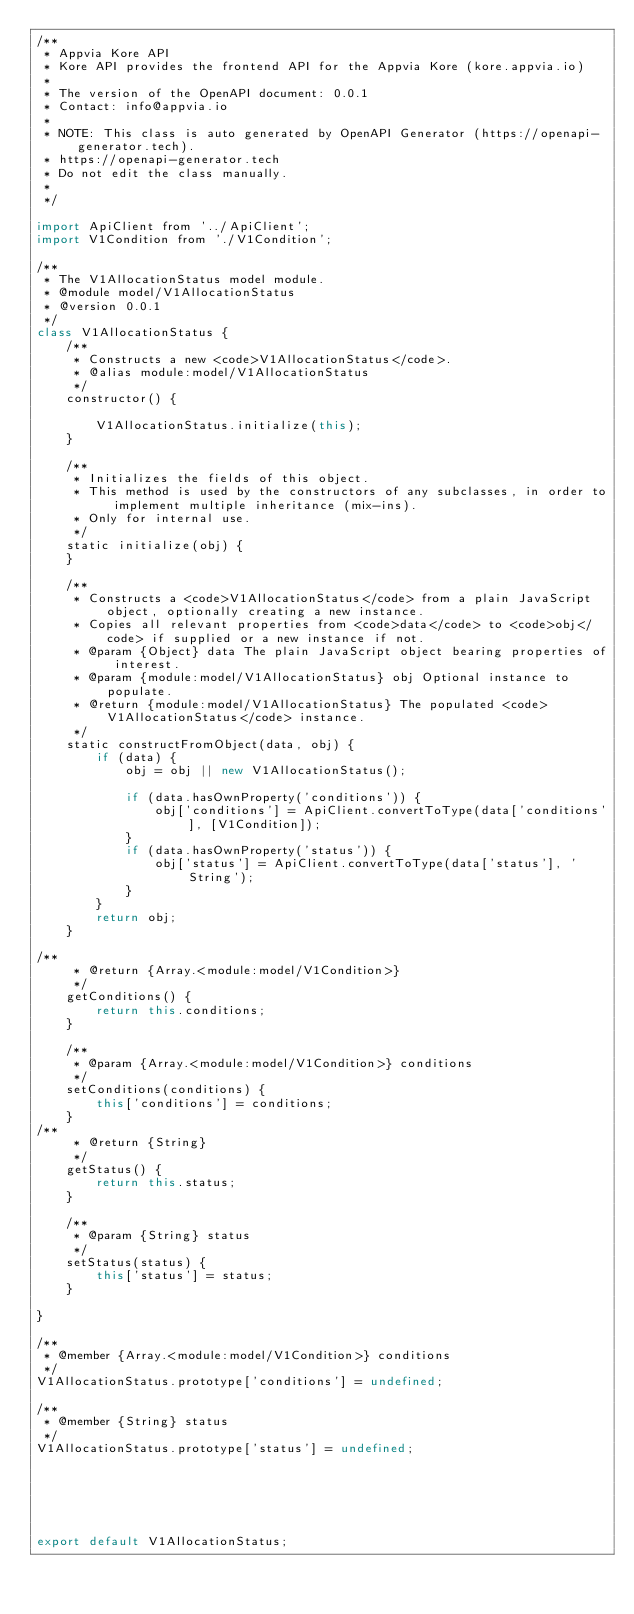Convert code to text. <code><loc_0><loc_0><loc_500><loc_500><_JavaScript_>/**
 * Appvia Kore API
 * Kore API provides the frontend API for the Appvia Kore (kore.appvia.io)
 *
 * The version of the OpenAPI document: 0.0.1
 * Contact: info@appvia.io
 *
 * NOTE: This class is auto generated by OpenAPI Generator (https://openapi-generator.tech).
 * https://openapi-generator.tech
 * Do not edit the class manually.
 *
 */

import ApiClient from '../ApiClient';
import V1Condition from './V1Condition';

/**
 * The V1AllocationStatus model module.
 * @module model/V1AllocationStatus
 * @version 0.0.1
 */
class V1AllocationStatus {
    /**
     * Constructs a new <code>V1AllocationStatus</code>.
     * @alias module:model/V1AllocationStatus
     */
    constructor() { 
        
        V1AllocationStatus.initialize(this);
    }

    /**
     * Initializes the fields of this object.
     * This method is used by the constructors of any subclasses, in order to implement multiple inheritance (mix-ins).
     * Only for internal use.
     */
    static initialize(obj) { 
    }

    /**
     * Constructs a <code>V1AllocationStatus</code> from a plain JavaScript object, optionally creating a new instance.
     * Copies all relevant properties from <code>data</code> to <code>obj</code> if supplied or a new instance if not.
     * @param {Object} data The plain JavaScript object bearing properties of interest.
     * @param {module:model/V1AllocationStatus} obj Optional instance to populate.
     * @return {module:model/V1AllocationStatus} The populated <code>V1AllocationStatus</code> instance.
     */
    static constructFromObject(data, obj) {
        if (data) {
            obj = obj || new V1AllocationStatus();

            if (data.hasOwnProperty('conditions')) {
                obj['conditions'] = ApiClient.convertToType(data['conditions'], [V1Condition]);
            }
            if (data.hasOwnProperty('status')) {
                obj['status'] = ApiClient.convertToType(data['status'], 'String');
            }
        }
        return obj;
    }

/**
     * @return {Array.<module:model/V1Condition>}
     */
    getConditions() {
        return this.conditions;
    }

    /**
     * @param {Array.<module:model/V1Condition>} conditions
     */
    setConditions(conditions) {
        this['conditions'] = conditions;
    }
/**
     * @return {String}
     */
    getStatus() {
        return this.status;
    }

    /**
     * @param {String} status
     */
    setStatus(status) {
        this['status'] = status;
    }

}

/**
 * @member {Array.<module:model/V1Condition>} conditions
 */
V1AllocationStatus.prototype['conditions'] = undefined;

/**
 * @member {String} status
 */
V1AllocationStatus.prototype['status'] = undefined;






export default V1AllocationStatus;

</code> 